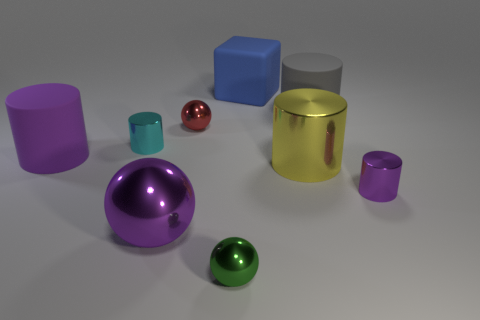There is a blue rubber thing behind the small metal thing that is on the right side of the tiny sphere in front of the tiny red sphere; what shape is it?
Provide a short and direct response. Cube. What number of green things are either large rubber blocks or large things?
Your answer should be compact. 0. There is a small metal cylinder on the left side of the green shiny thing; what number of large metallic things are to the left of it?
Give a very brief answer. 0. Is there anything else that is the same color as the large cube?
Make the answer very short. No. What shape is the cyan thing that is made of the same material as the big sphere?
Your answer should be compact. Cylinder. Is the big matte cube the same color as the large sphere?
Give a very brief answer. No. Is the purple cylinder that is right of the blue block made of the same material as the small cylinder left of the red ball?
Ensure brevity in your answer.  Yes. How many things are either purple metallic spheres or things that are left of the big gray matte thing?
Ensure brevity in your answer.  7. Is there anything else that is the same material as the tiny cyan cylinder?
Your answer should be compact. Yes. There is a tiny object that is the same color as the large metal sphere; what is its shape?
Your answer should be very brief. Cylinder. 